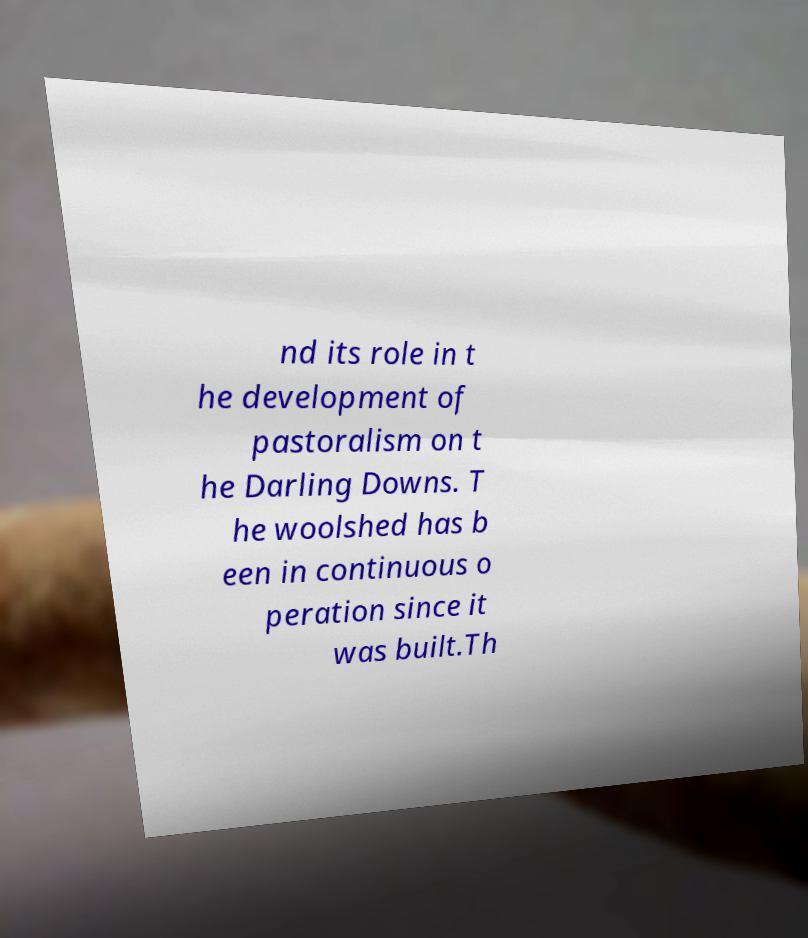Could you extract and type out the text from this image? nd its role in t he development of pastoralism on t he Darling Downs. T he woolshed has b een in continuous o peration since it was built.Th 